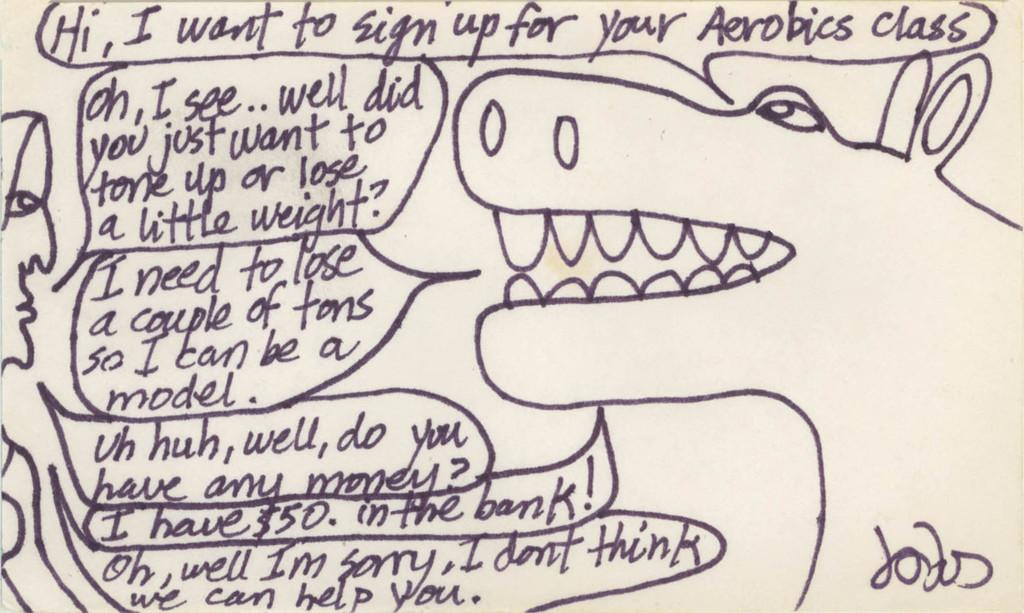What is the medium of the image? The image is on a paper. What else can be found on the paper besides the image? There is writing and a drawing on the paper. What type of hat is being worn by the lettuce in the image? There is no hat or lettuce present in the image; it only contains writing and a drawing on a paper. 